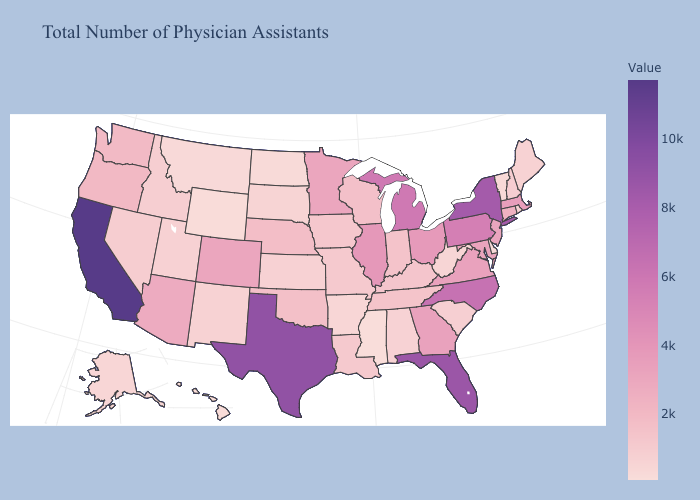Does California have the highest value in the USA?
Be succinct. Yes. Does New Jersey have the highest value in the Northeast?
Short answer required. No. Among the states that border New Jersey , does New York have the highest value?
Write a very short answer. Yes. Among the states that border Tennessee , does North Carolina have the highest value?
Write a very short answer. Yes. Among the states that border New York , does Pennsylvania have the lowest value?
Keep it brief. No. Does Connecticut have a lower value than Idaho?
Quick response, please. No. Does Kentucky have the lowest value in the USA?
Write a very short answer. No. Does Kentucky have the lowest value in the South?
Write a very short answer. No. 